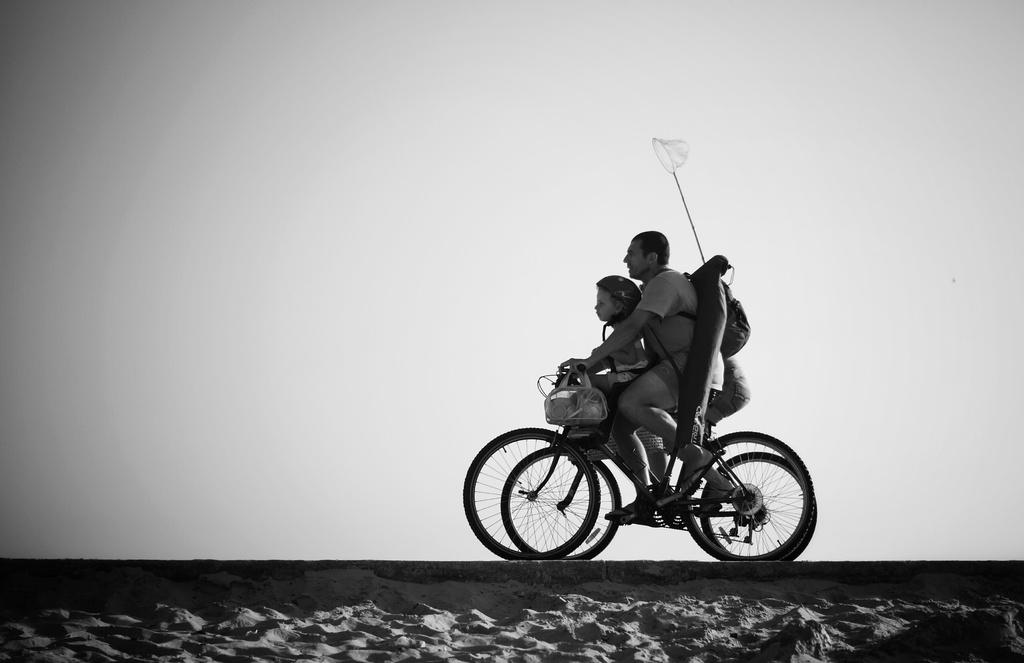How many people are in the image? There are two people in the image. What are the two people doing in the image? The two people are riding a bicycle. What type of spade is being used by one of the people in the image? There is no spade present in the image; the two people are riding a bicycle. 